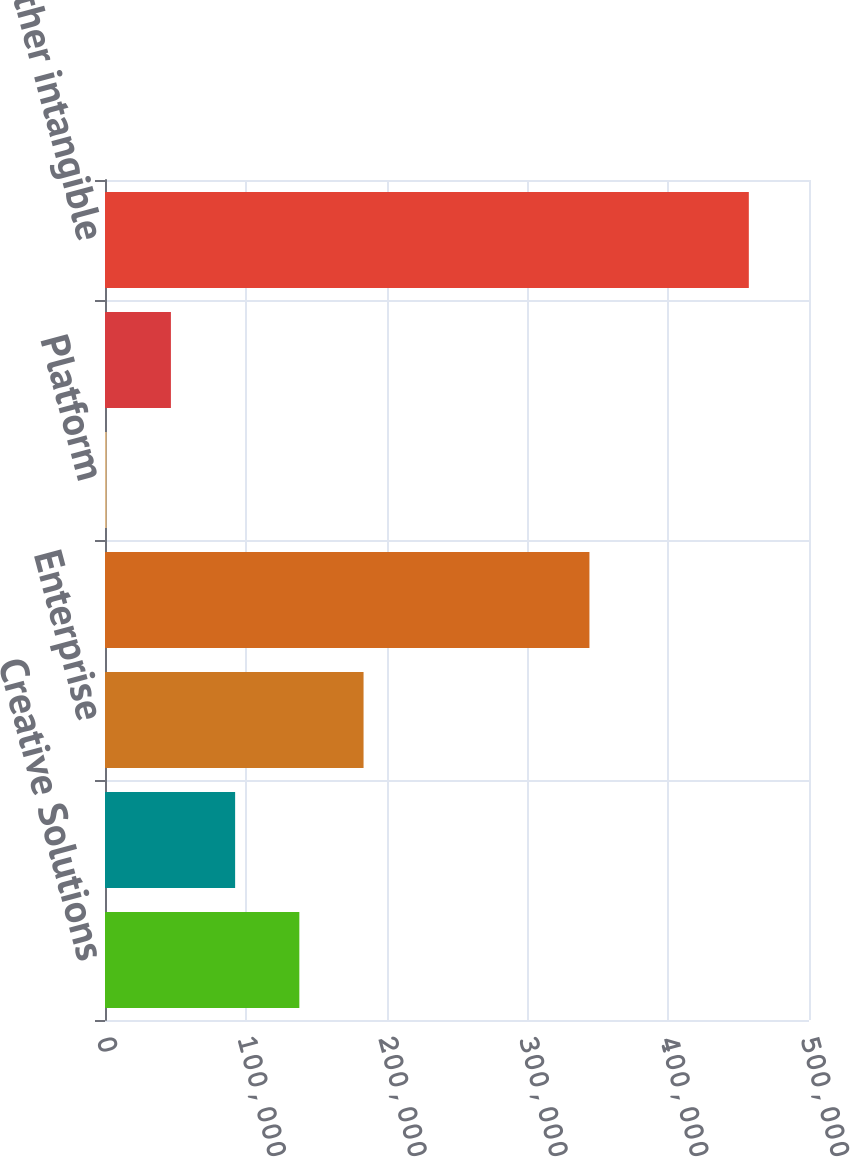Convert chart to OTSL. <chart><loc_0><loc_0><loc_500><loc_500><bar_chart><fcel>Creative Solutions<fcel>Knowledge Worker<fcel>Enterprise<fcel>Omniture<fcel>Platform<fcel>Print and Publishing<fcel>Purchased and other intangible<nl><fcel>138024<fcel>92419<fcel>183630<fcel>344059<fcel>1208<fcel>46813.5<fcel>457263<nl></chart> 